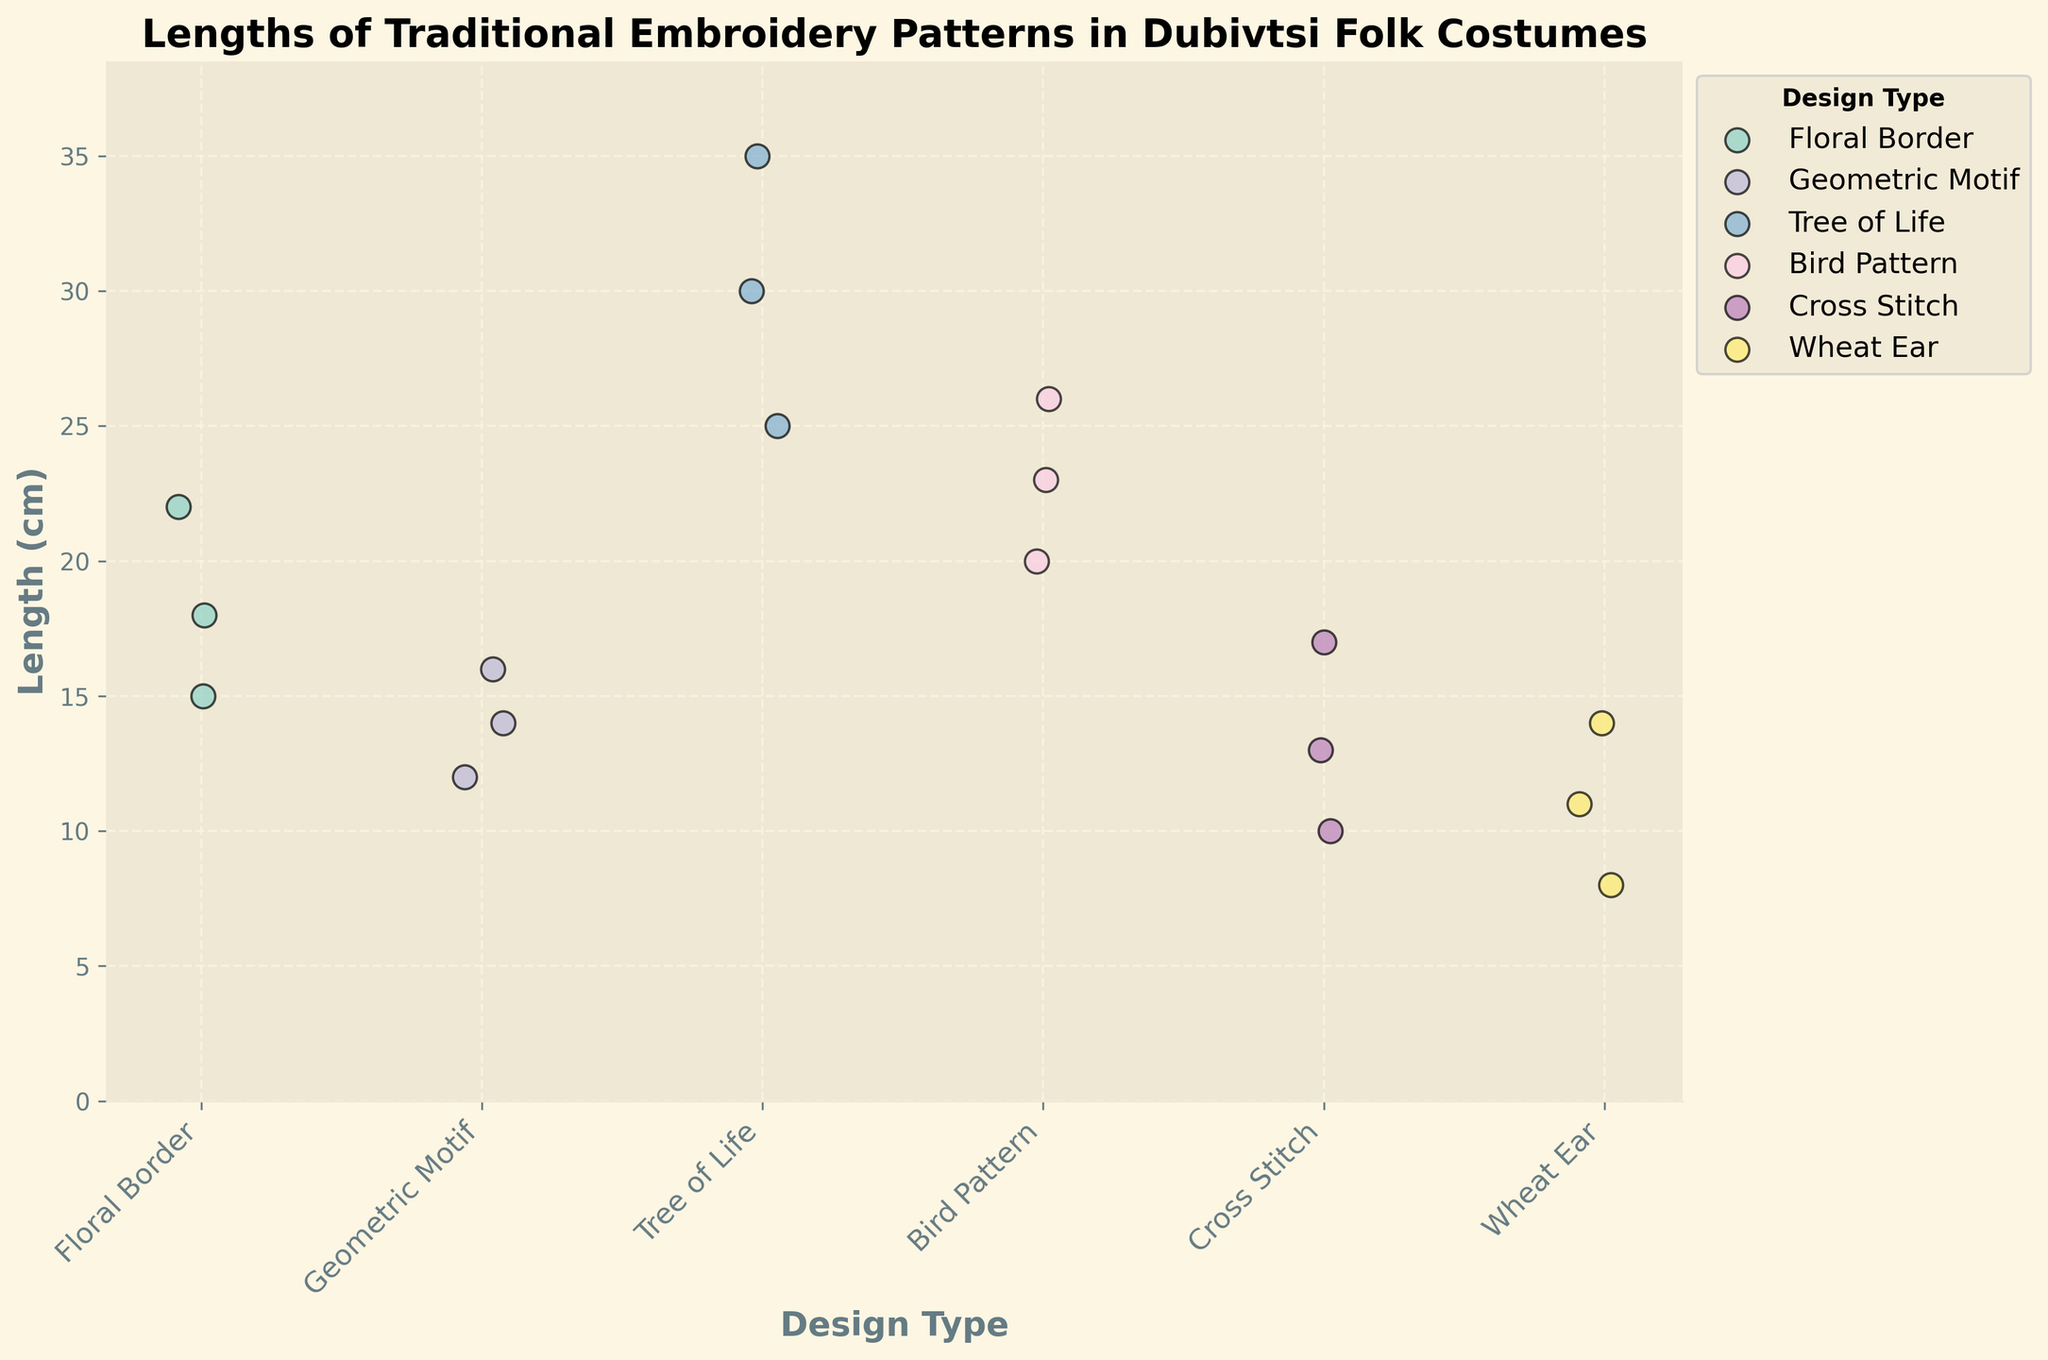what's the title of the figure? The title of the figure is always located at the top and is usually larger and bolder than other texts. In this case, it reads "Lengths of Traditional Embroidery Patterns in Dubivtsi Folk Costumes".
Answer: Lengths of Traditional Embroidery Patterns in Dubivtsi Folk Costumes Which design type has the longest individual embroidery pattern? To find the longest pattern, look at the y-axis and identify the design type with the highest data point. The highest point is at 35 cm under "Tree of Life".
Answer: Tree of Life How many design types are compared in this plot? The x-axis of the plot shows the categories of design types. By counting the unique labels on the x-axis, you can determine the number of design types. There are six design types.
Answer: 6 What's the average length of the "Bird Pattern" embroidery? To calculate the average, add the lengths of the "Bird Pattern" design and then divide by the number of data points. (20 + 23 + 26) / 3 = 23 cm.
Answer: 23 cm Which design type shows the smallest individual length? Examine the lowest points across all design types on the y-axis to find the smallest length. The lowest point belongs to "Wheat Ear" with a length of 8 cm.
Answer: Wheat Ear Which design type has the most data points? Check the scatter points for each design type along the x-axis to see which one has the most points. Both "Floral Border" and "Tree of Life" have 3 data points each, but since all design types have equal data points, count any one.
Answer: All the same (3) Is there any design type where the lengths range spans more than 10 cm? For this question, look at the difference between the maximum and minimum lengths within a design type. "Tree of Life" ranges from 25 cm to 35 cm, making it a range of 10 cm. Since it's exactly 10 cm, none span more than 10 cm.
Answer: No What's the difference in the longest length between "Floral Border" and "Geometric Motif"? The longest length for "Floral Border" is 22 cm and for "Geometric Motif" it's 16 cm. The difference is 22 - 16 = 6 cm.
Answer: 6 cm Do any two design types have the same minimum value? Check the smallest value point across all design types to see if any match. No two types share the same minimum value.
Answer: No 